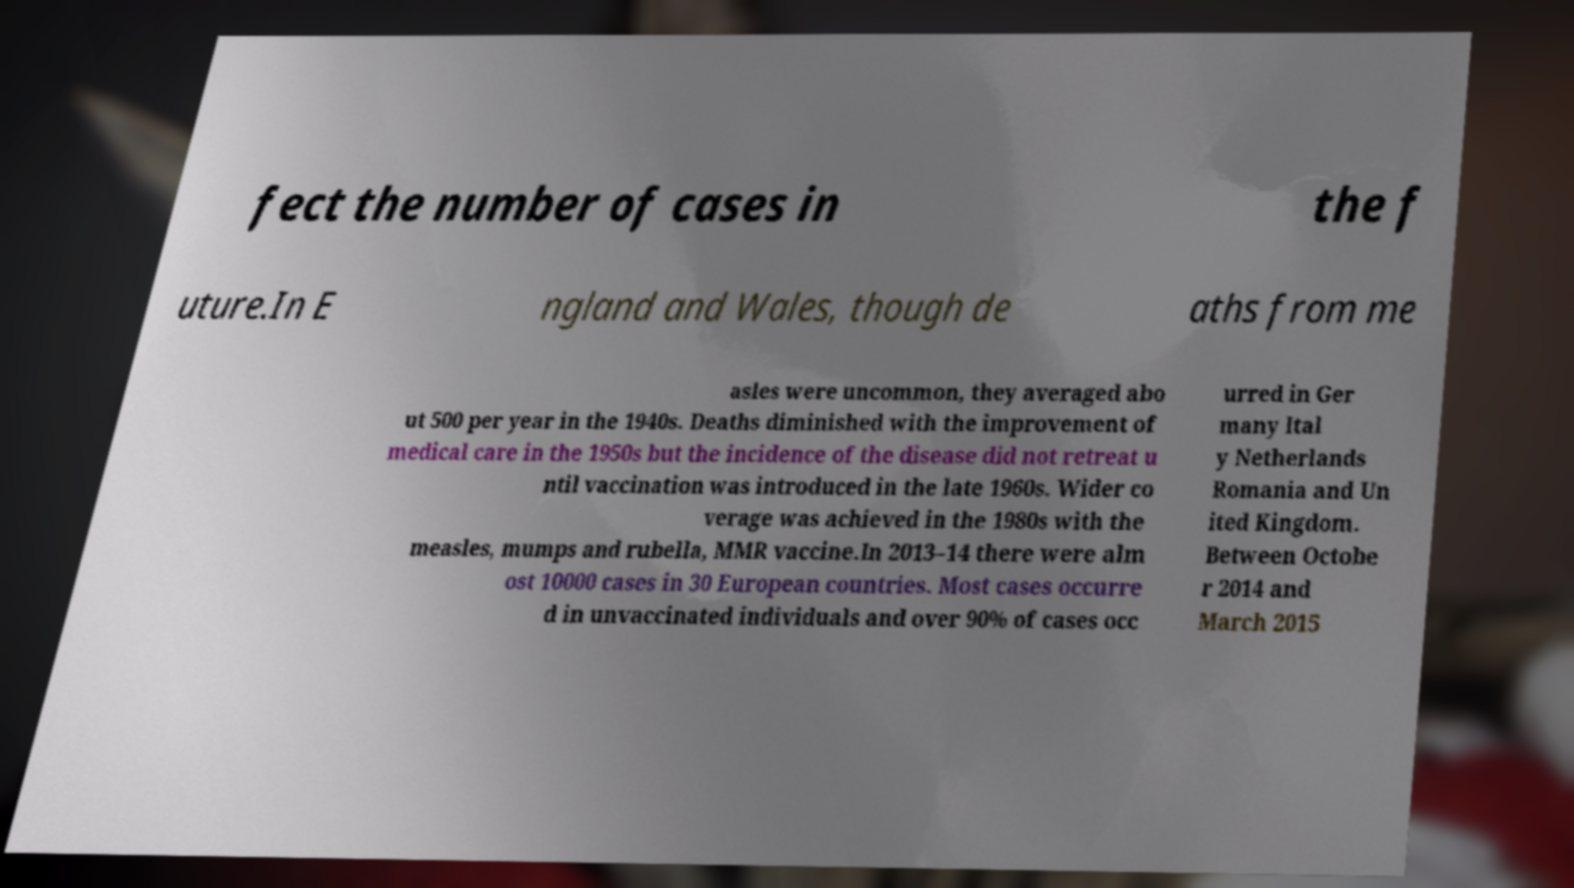What messages or text are displayed in this image? I need them in a readable, typed format. fect the number of cases in the f uture.In E ngland and Wales, though de aths from me asles were uncommon, they averaged abo ut 500 per year in the 1940s. Deaths diminished with the improvement of medical care in the 1950s but the incidence of the disease did not retreat u ntil vaccination was introduced in the late 1960s. Wider co verage was achieved in the 1980s with the measles, mumps and rubella, MMR vaccine.In 2013–14 there were alm ost 10000 cases in 30 European countries. Most cases occurre d in unvaccinated individuals and over 90% of cases occ urred in Ger many Ital y Netherlands Romania and Un ited Kingdom. Between Octobe r 2014 and March 2015 